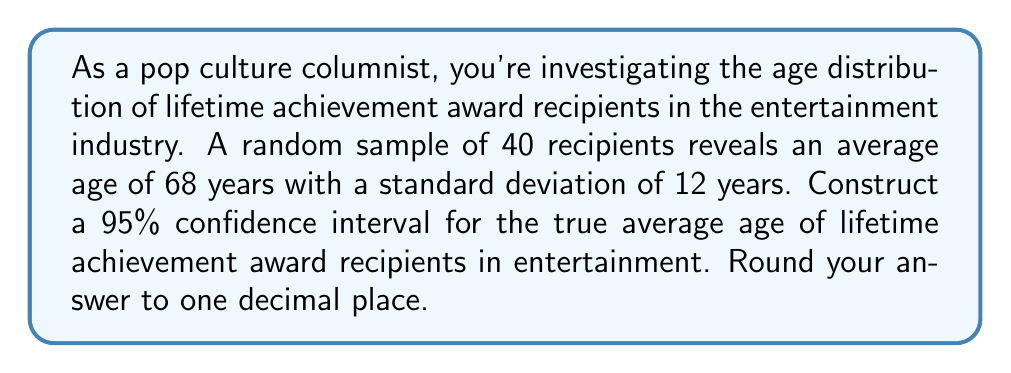Give your solution to this math problem. Let's approach this step-by-step:

1) We're dealing with a confidence interval for a population mean with unknown population standard deviation. We'll use the t-distribution.

2) Given information:
   - Sample size: $n = 40$
   - Sample mean: $\bar{x} = 68$ years
   - Sample standard deviation: $s = 12$ years
   - Confidence level: 95% (α = 0.05)

3) The formula for the confidence interval is:

   $$\bar{x} \pm t_{\alpha/2, n-1} \cdot \frac{s}{\sqrt{n}}$$

4) Find the t-value:
   - Degrees of freedom: $df = n - 1 = 39$
   - For a 95% confidence interval, $\alpha/2 = 0.025$
   - From t-table or calculator: $t_{0.025, 39} \approx 2.023$

5) Calculate the margin of error:

   $$\text{Margin of Error} = t_{0.025, 39} \cdot \frac{s}{\sqrt{n}} = 2.023 \cdot \frac{12}{\sqrt{40}} \approx 3.84$$

6) Construct the confidence interval:

   $$68 \pm 3.84$$

   Lower bound: $68 - 3.84 = 64.16$
   Upper bound: $68 + 3.84 = 71.84$

7) Rounding to one decimal place:

   $(64.2, 71.8)$
Answer: (64.2, 71.8) 